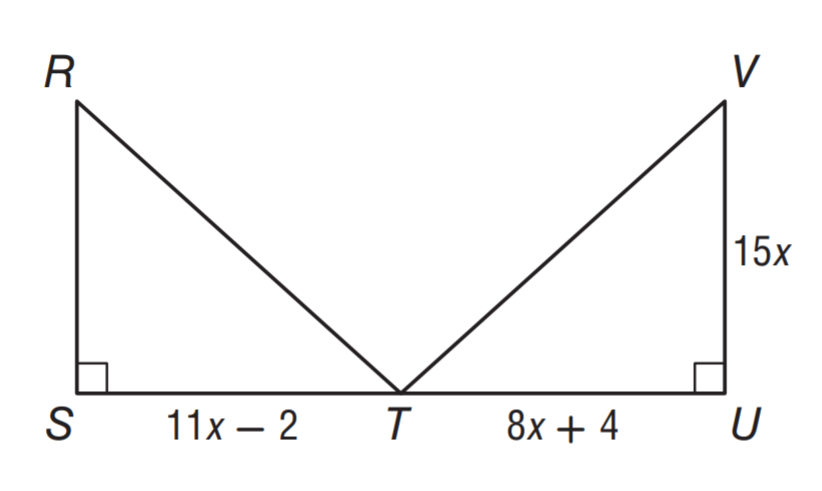Answer the mathemtical geometry problem and directly provide the correct option letter.
Question: \triangle R S T \cong \triangle V U T. What is the area of \triangle R S T?
Choices: A: 150 B: 300 C: 450 D: 600 B 